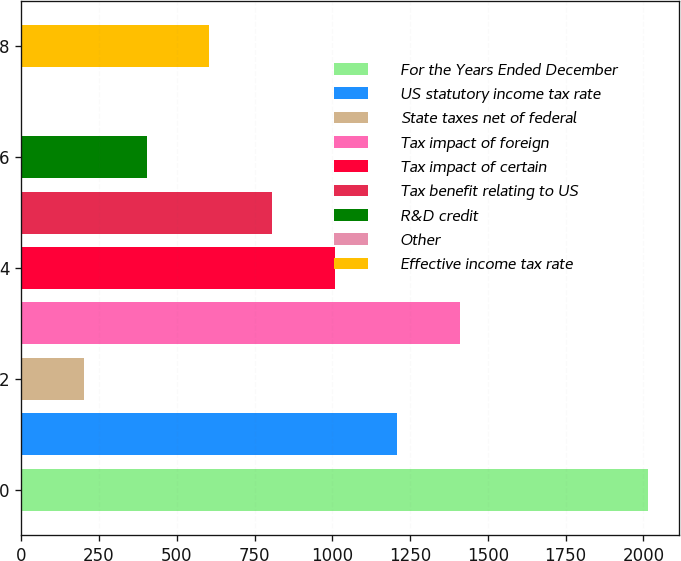Convert chart to OTSL. <chart><loc_0><loc_0><loc_500><loc_500><bar_chart><fcel>For the Years Ended December<fcel>US statutory income tax rate<fcel>State taxes net of federal<fcel>Tax impact of foreign<fcel>Tax impact of certain<fcel>Tax benefit relating to US<fcel>R&D credit<fcel>Other<fcel>Effective income tax rate<nl><fcel>2015<fcel>1209.24<fcel>202.04<fcel>1410.68<fcel>1007.8<fcel>806.36<fcel>403.48<fcel>0.6<fcel>604.92<nl></chart> 